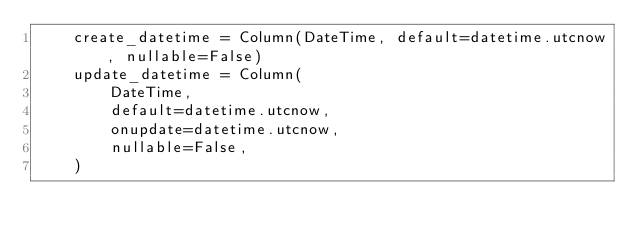Convert code to text. <code><loc_0><loc_0><loc_500><loc_500><_Python_>    create_datetime = Column(DateTime, default=datetime.utcnow, nullable=False)
    update_datetime = Column(
        DateTime,
        default=datetime.utcnow,
        onupdate=datetime.utcnow,
        nullable=False,
    )
</code> 